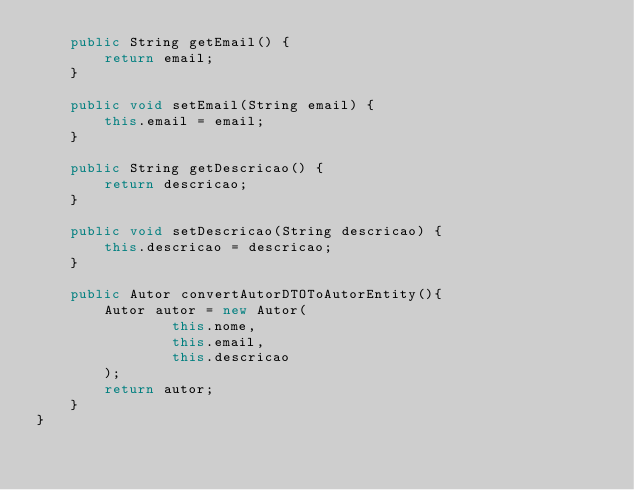Convert code to text. <code><loc_0><loc_0><loc_500><loc_500><_Java_>    public String getEmail() {
        return email;
    }

    public void setEmail(String email) {
        this.email = email;
    }

    public String getDescricao() {
        return descricao;
    }

    public void setDescricao(String descricao) {
        this.descricao = descricao;
    }

    public Autor convertAutorDTOToAutorEntity(){
        Autor autor = new Autor(
                this.nome,
                this.email,
                this.descricao
        );
        return autor;
    }
}
</code> 